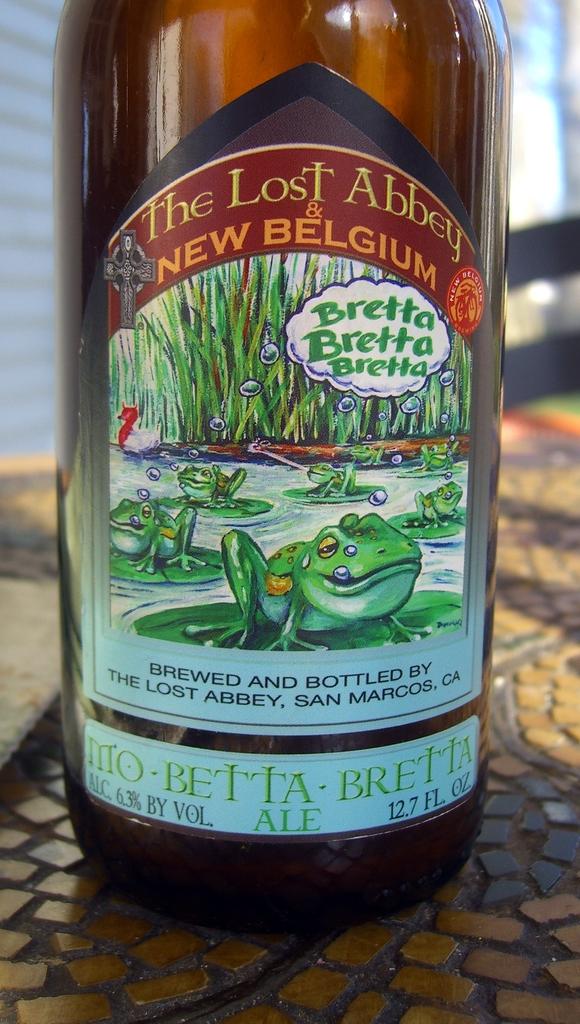Who is this beverage brewed and bottled by?
Make the answer very short. The lost abbey. How many ounces are in the bottle?
Make the answer very short. 12.7. 